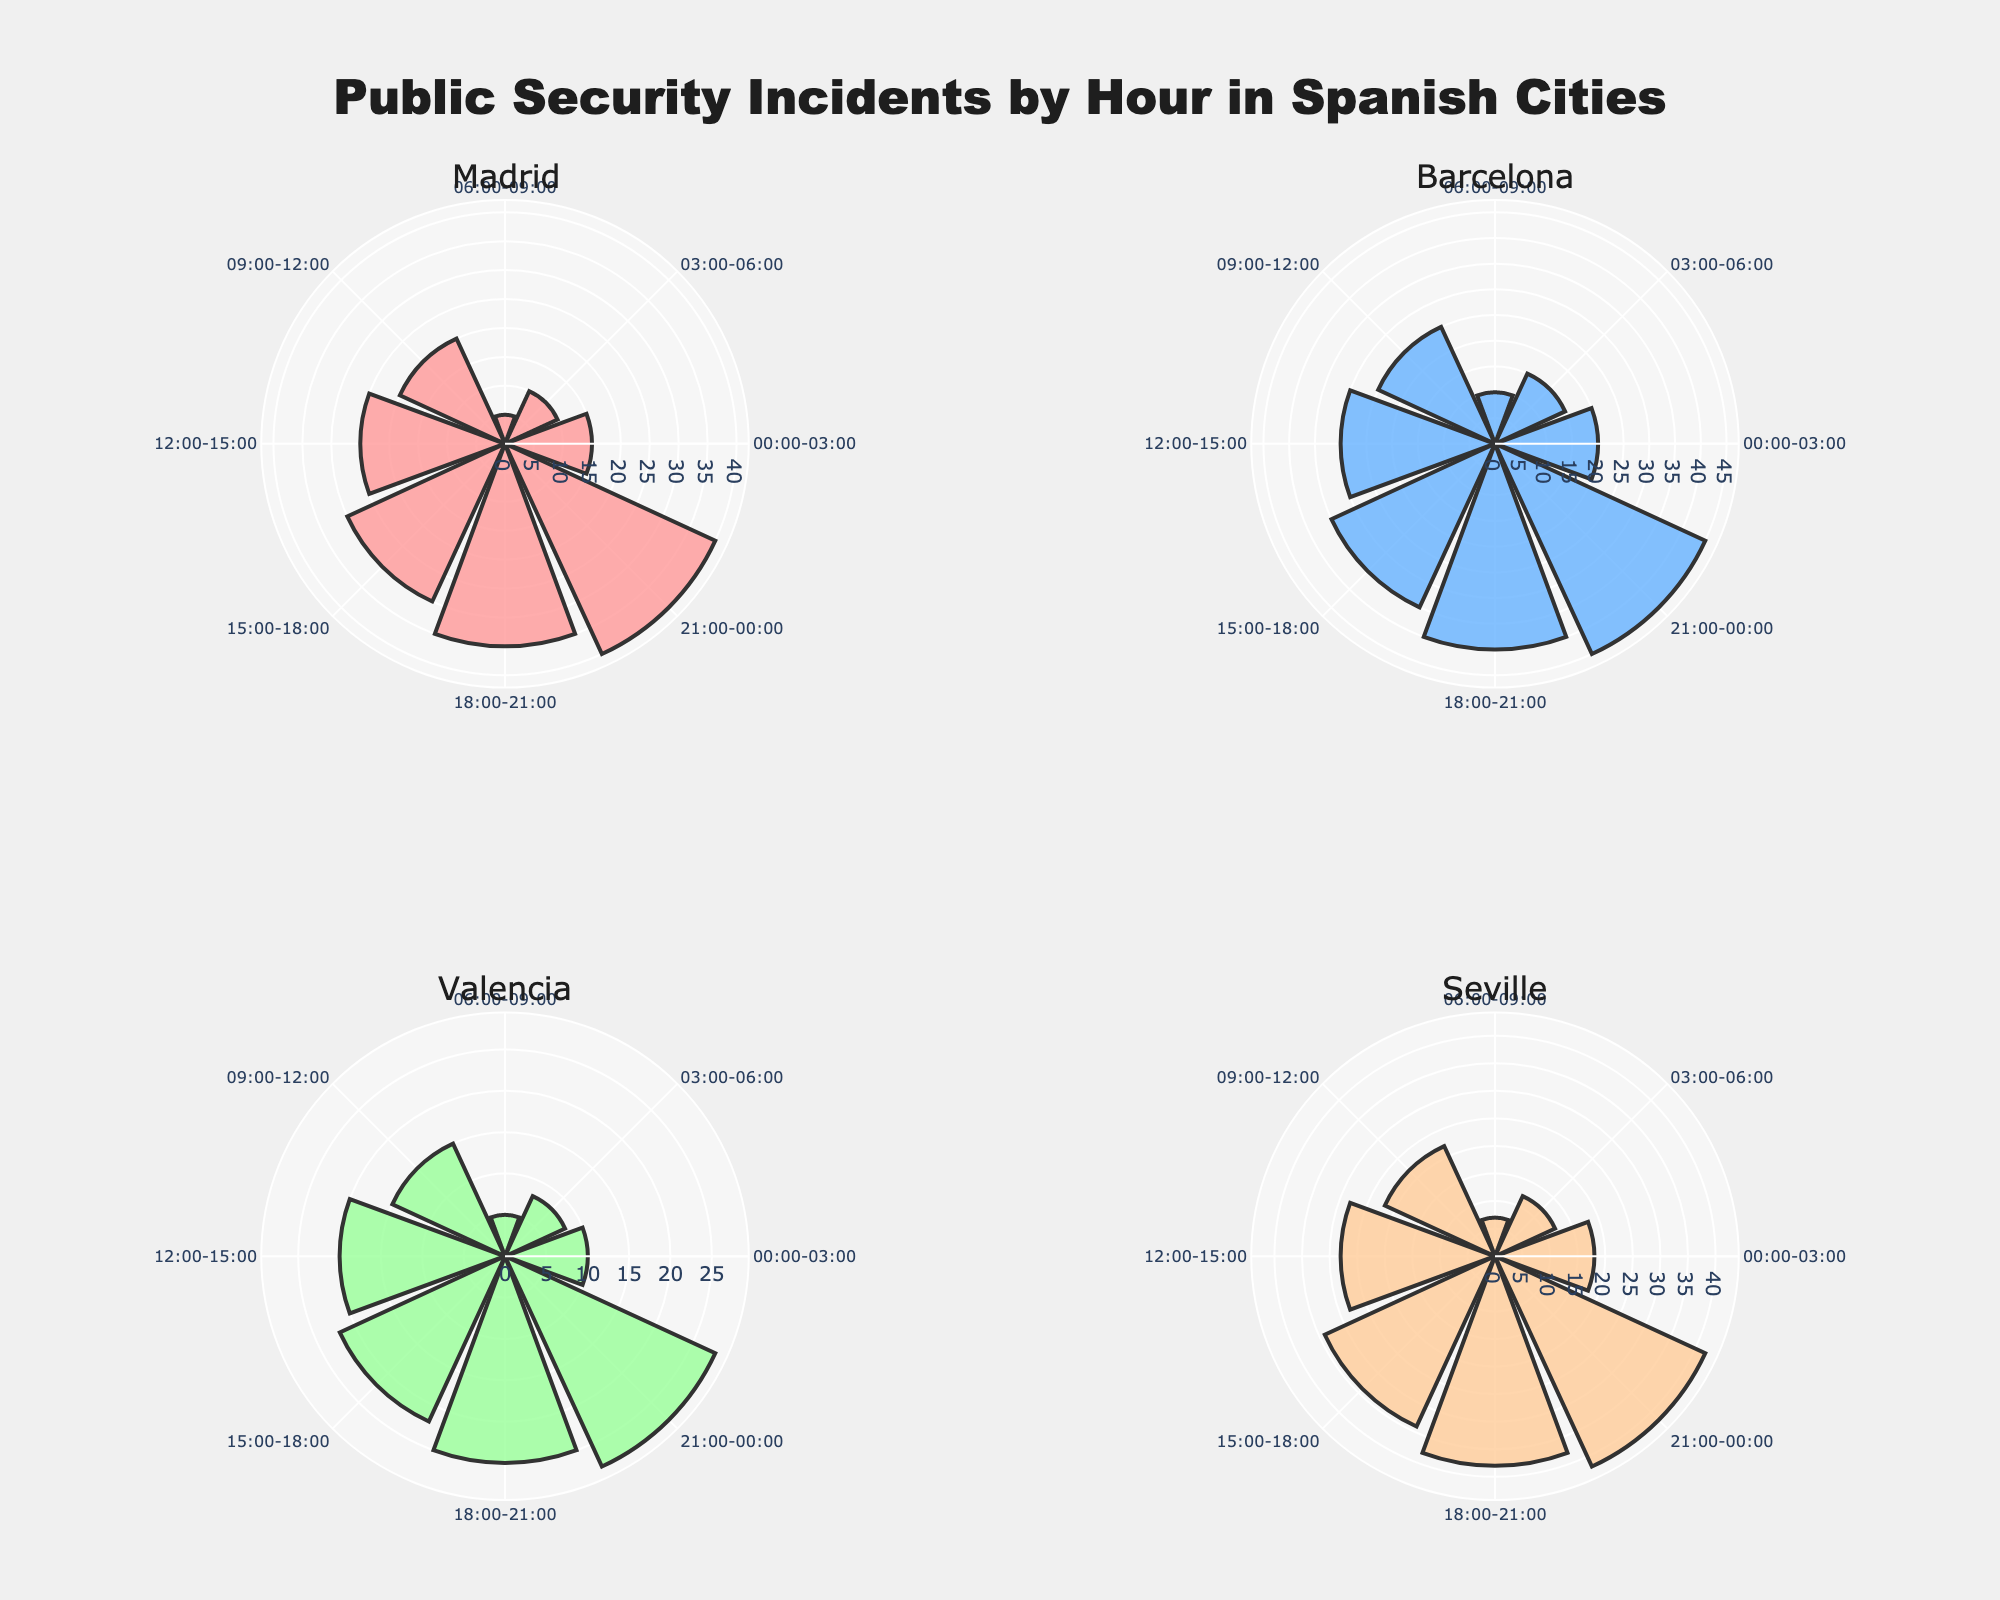¿Cuál ciudad tiene el mayor número de incidentes de seguridad pública a las 21:00-00:00? Al observar las barras polares en el gráfico, Seville tiene el número más alto de incidentes de seguridad pública en ese periodo, con 42 incidentes.
Answer: Seville ¿Cuántos incidentes de seguridad pública ocurrieron en Madrid entre las 00:00-06:00? Al sumar los incidentes de las barras polares de los periodos 00:00-03:00 y 03:00-06:00 en el gráfico correspondiente a Madrid (15 + 10), obtenemos 25 incidentes.
Answer: 25 Comparado con Valencia, ¿Barcelona tiene más o menos incidentes de seguridad pública a las 18:00-21:00? Observando el gráfico, Barcelona tiene 40 incidentes, mientras que Valencia tiene 25 incidentes en el mismo periodo. Por lo tanto, Barcelona tiene más incidentes.
Answer: Más ¿Cuántos incidentes de seguridad pública ocurrieron en total en el gráfico de Madrid? Sumamos todas las barras polares en el gráfico de Madrid: 15 + 10 + 5 + 20 + 25 + 30 + 35 + 40 = 180
Answer: 180 ¿Qué ciudad tiene la menor cantidad de incidentes de seguridad pública a las 06:00-09:00? Al comparar las barras polares de ese periodo en cada gráfico de la ciudad, Valencia tiene el menor número de incidentes con 5.
Answer: Valencia 